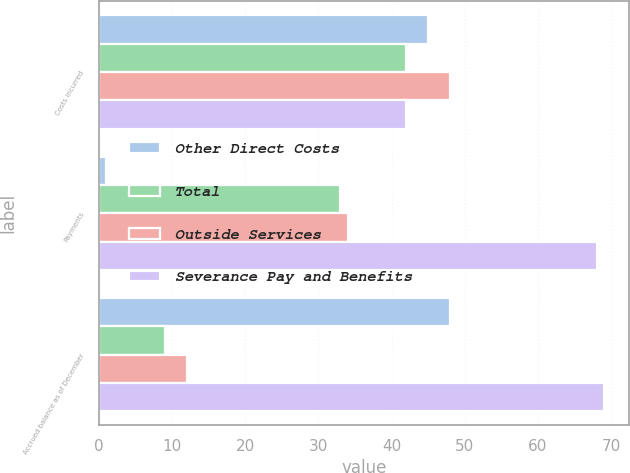Convert chart. <chart><loc_0><loc_0><loc_500><loc_500><stacked_bar_chart><ecel><fcel>Costs incurred<fcel>Payments<fcel>Accrued balance as of December<nl><fcel>Other Direct Costs<fcel>45<fcel>1<fcel>48<nl><fcel>Total<fcel>42<fcel>33<fcel>9<nl><fcel>Outside Services<fcel>48<fcel>34<fcel>12<nl><fcel>Severance Pay and Benefits<fcel>42<fcel>68<fcel>69<nl></chart> 